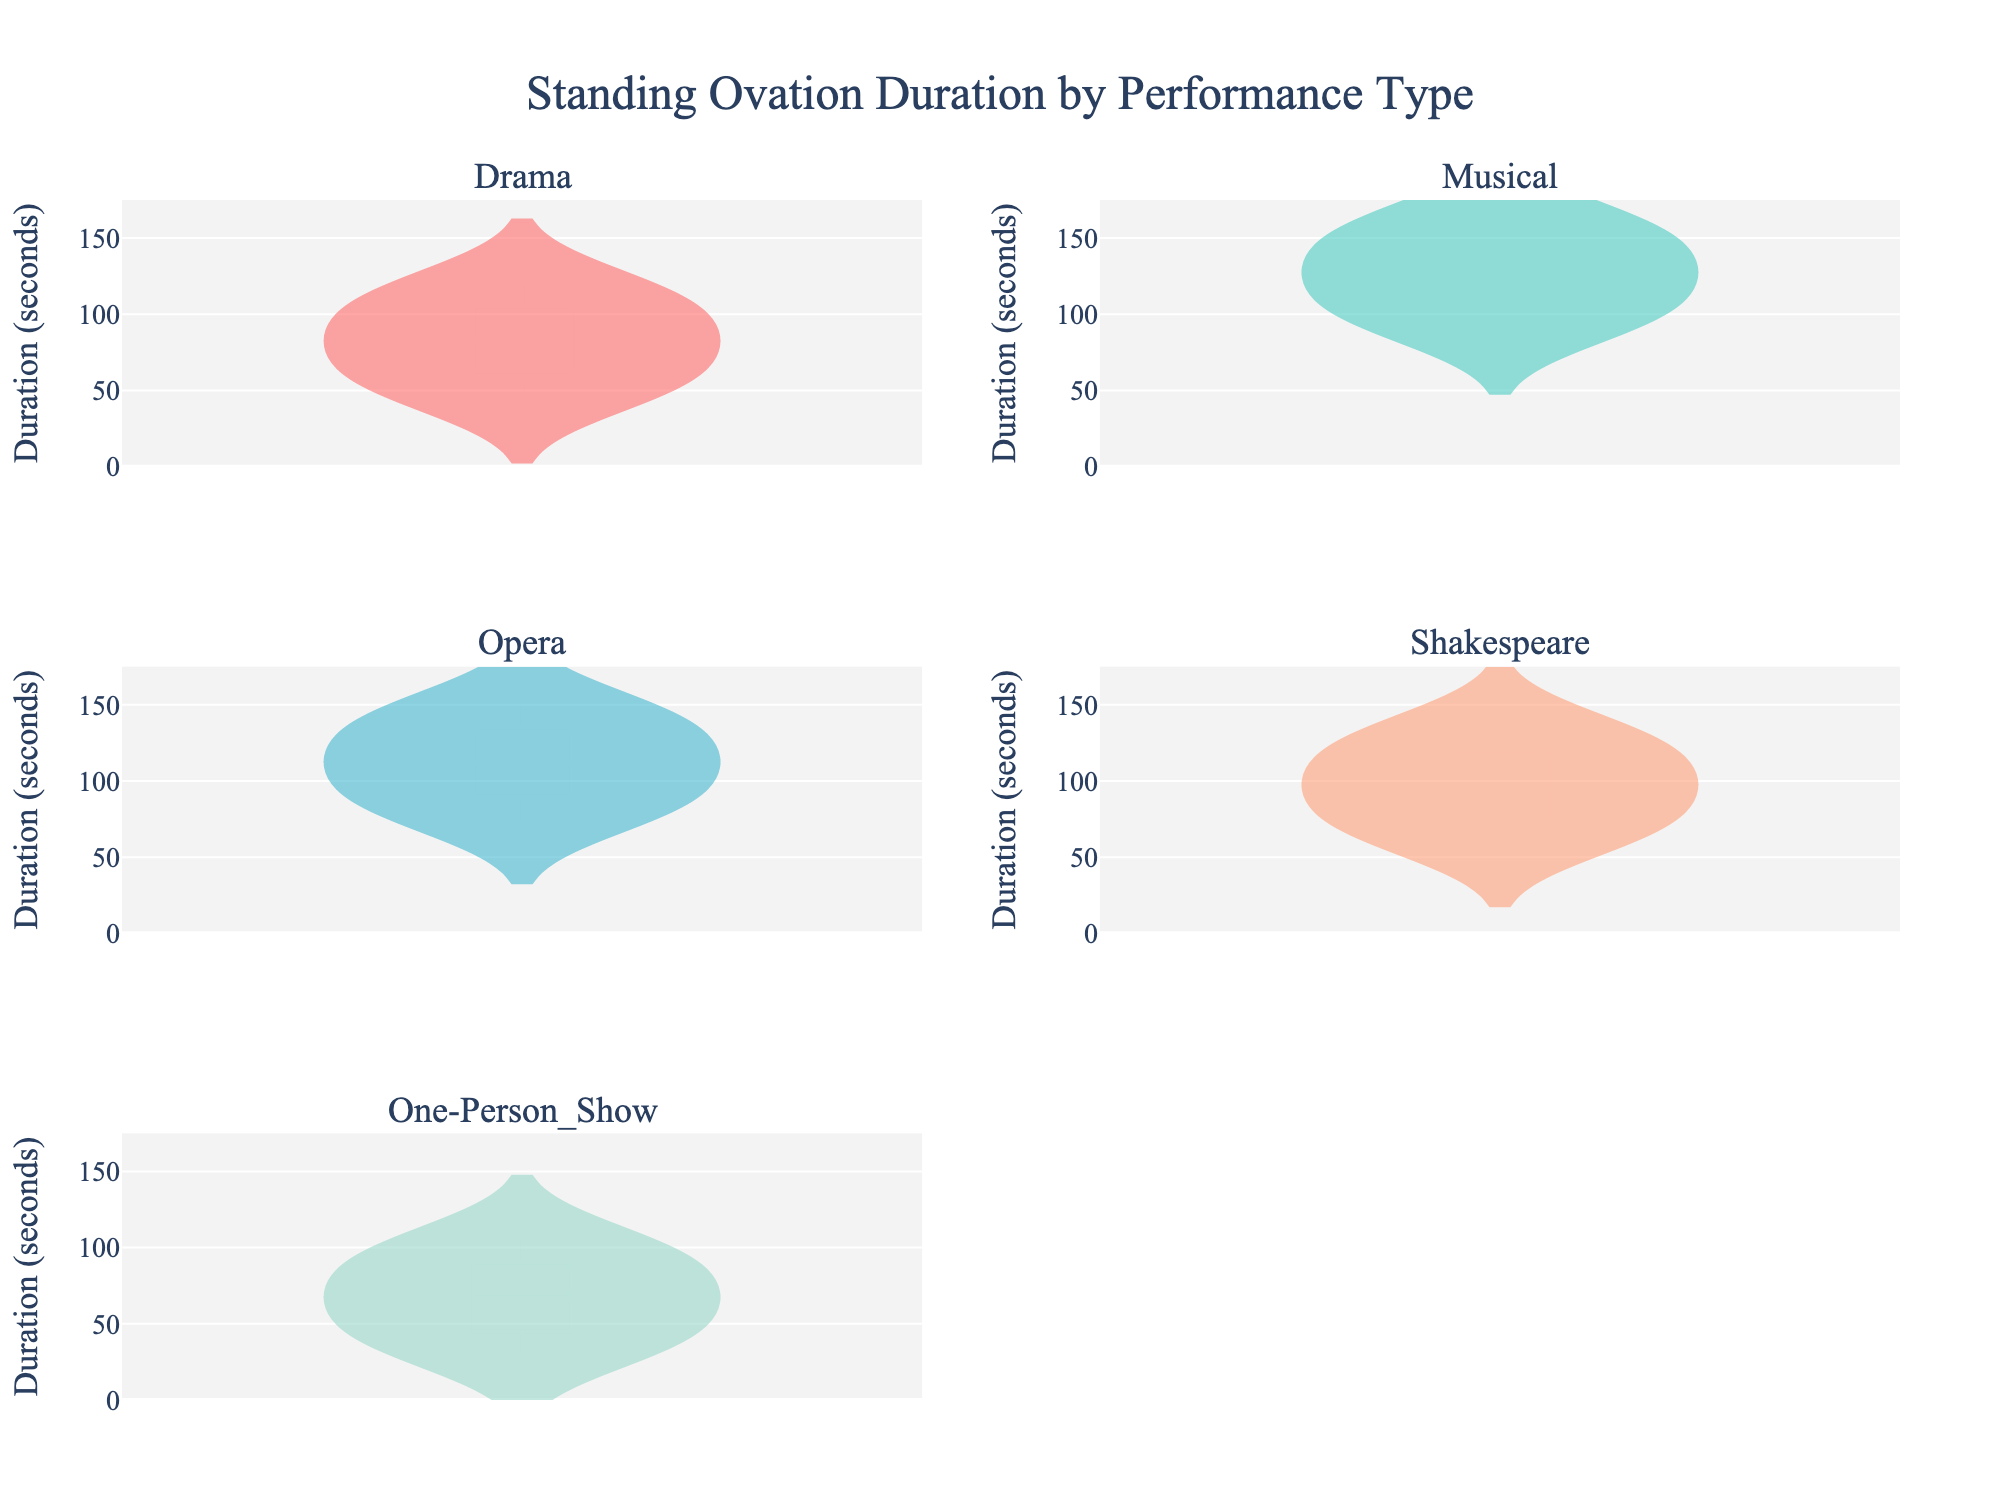what does the title of the figure tell us? The title "Standing Ovation Duration by Performance Type" indicates that the figure is displaying the duration of standing ovations for different types of performances. This helps understand that the plot compares the time lengths of applause for the categories like Drama, Musical, Opera, etc.
Answer: Standing Ovation Duration by Performance Type How many types of performances are compared in the figure? By counting the subplot titles, the figure compares six types of performances. These are: Drama, Musical, Opera, Shakespeare, One-Person Show.
Answer: Six Which performance type has the lowest minimum duration of standing ovations? Looking at the bottom y-values of the violins, One-Person Show has the lowest minimum value at approximately 30 seconds.
Answer: One-Person Show What is the range of standing ovation durations for Musicals? The violin plot for Musicals spans from approximately 90 to 165 seconds, making the range 75 seconds.
Answer: 75 seconds Which performance type seems to have the widest distribution of standing ovation durations? By assessing the width of the violin plots, One-Person Show shows the widest distribution with durations ranging from about 30 to 105 seconds.
Answer: One-Person Show Which performance type has the highest maximum duration of standing ovations? Checking the top y-values of the violins, Musicals have the highest maximum value at approximately 165 seconds.
Answer: Musicals What is the median duration of standing ovations for Shakespeare shows? With the presence of a median line in the violin plot, it shows that Shakespeare has a median approximately at 97.5 seconds.
Answer: 97.5 seconds Is the distribution of standing ovations for Drama skewed? If yes, in which direction? Observing the shape of the violin plot for Drama, it is slightly skewed towards longer durations, indicating a right skew.
Answer: Right If we combine Drama and Opera durations, what is the median of the combined durations? First, combine the values: Drama (45, 60, 75, 90, 105, 120), Opera (75, 90, 105, 120, 135, 150). The combined sorted durations are: (45, 60, 75, 75, 90, 90, 105, 105, 120, 120, 135, 150). The median is the average of the 6th and 7th values, i.e. (90+105)/2 = 97.5.
Answer: 97.5 Which performance type has the most consistent (least spread) duration of standing ovations? By observing the violin plots, Shakespeare appears to have the most consistent durations ranging from about 60 to 135 seconds.
Answer: Shakespeare 